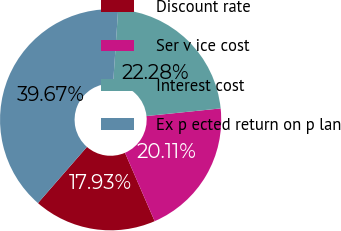<chart> <loc_0><loc_0><loc_500><loc_500><pie_chart><fcel>Discount rate<fcel>Ser v ice cost<fcel>Interest cost<fcel>Ex p ected return on p lan<nl><fcel>17.93%<fcel>20.11%<fcel>22.28%<fcel>39.67%<nl></chart> 